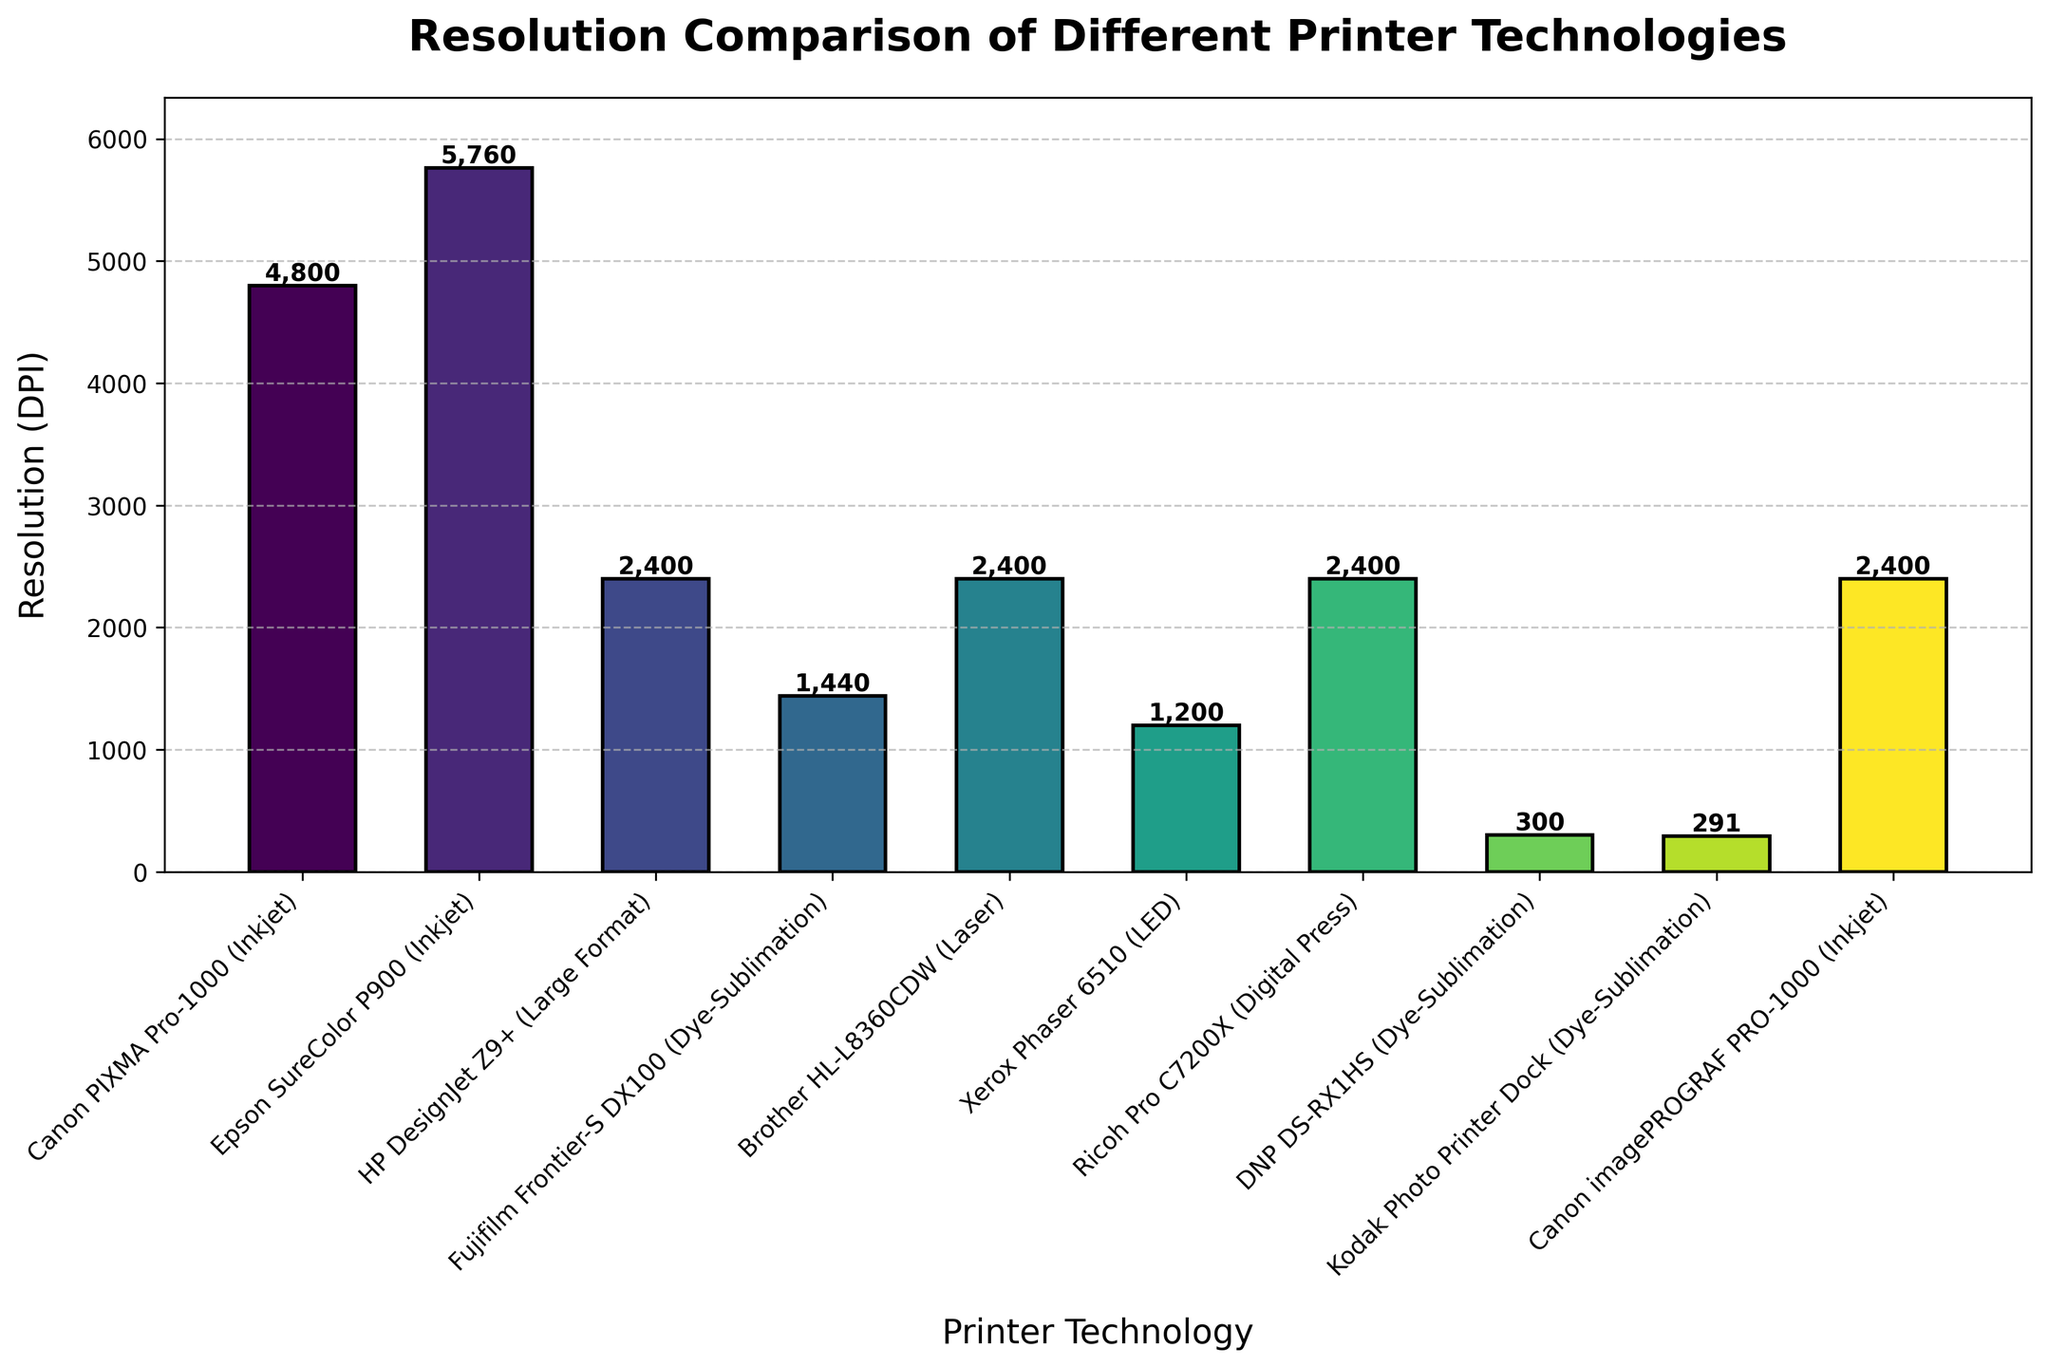Which printer technology has the highest resolution? By looking at the bar heights, the Epson SureColor P900 (Inkjet) has the tallest bar, indicating it has the highest resolution of all the printer technologies shown.
Answer: Epson SureColor P900 (Inkjet) What is the resolution difference between the Canon PIXMA Pro-1000 and the HP DesignJet Z9+? The Canon PIXMA Pro-1000 has a resolution of 4800 DPI, while the HP DesignJet Z9+ has a resolution of 2400 DPI. The difference is 4800 - 2400 = 2400 DPI.
Answer: 2400 DPI Which printer technology has the lowest resolution? The shortest bar corresponds to the Kodak Photo Printer Dock (Dye-Sublimation) with a resolution of 291 DPI.
Answer: Kodak Photo Printer Dock (Dye-Sublimation) Among the dye-sublimation technologies, which one has the highest resolution? Comparing the heights of bars for dye-sublimation technologies (Fujifilm Frontier-S DX100, DNP DS-RX1HS, and Kodak Photo Printer Dock), the Fujifilm Frontier-S DX100 has the tallest bar with a resolution of 1440 DPI.
Answer: Fujifilm Frontier-S DX100 What is the average resolution of the laser and LED printer technologies shown? The Brother HL-L8360CDW (Laser) and Xerox Phaser 6510 (LED) each have a resolution of 2400 DPI and 1200 DPI, respectively. The average is (2400 + 1200) / 2 = 1800 DPI.
Answer: 1800 DPI Is the resolution of the Ricoh Pro C7200X (Digital Press) higher or lower than the average resolution of all printers shown? First, calculate the average resolution of all printers: (4800 + 5760 + 2400 + 1440 + 2400 + 1200 + 2400 + 300 + 291 + 2400) / 10 = 2349.1 DPI. The Ricoh Pro C7200X has a resolution of 2400 DPI, which is slightly higher than the average.
Answer: Higher How many printers have a resolution equal to or greater than 2400 DPI? By counting the bars with heights equal to or greater than 2400: Canon PIXMA Pro-1000, Epson SureColor P900, HP DesignJet Z9+, Brother HL-L8360CDW, Ricoh Pro C7200X, Canon imagePROGRAF PRO-1000.
Answer: 6 What is the median resolution of the listed printer technologies? First, list the resolutions in ascending order: 291, 300, 1200, 1440, 2400, 2400, 2400, 4800, 5760. After sorting, the median resolution (4th and 5th values average) is (2400 + 2400) / 2 = 2400 DPI.
Answer: 2400 DPI 